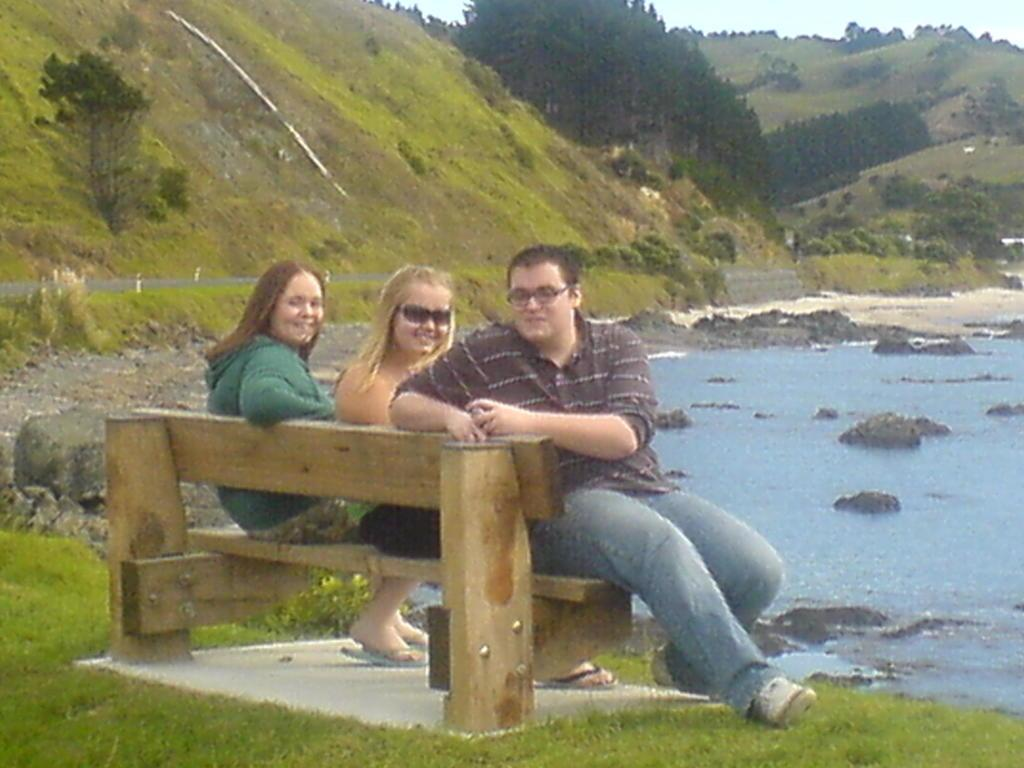How many people are in the image? There are two women and a man in the image. What is the man doing in the image? The man is sitting on a bench in the image. Where is the bench located? The bench is in front of a lake in the image. What can be seen in the background of the image? There are trees and a mountain visible in the image. What color are the eyes of the snails in the image? There are no snails present in the image, so their eyes cannot be described. 